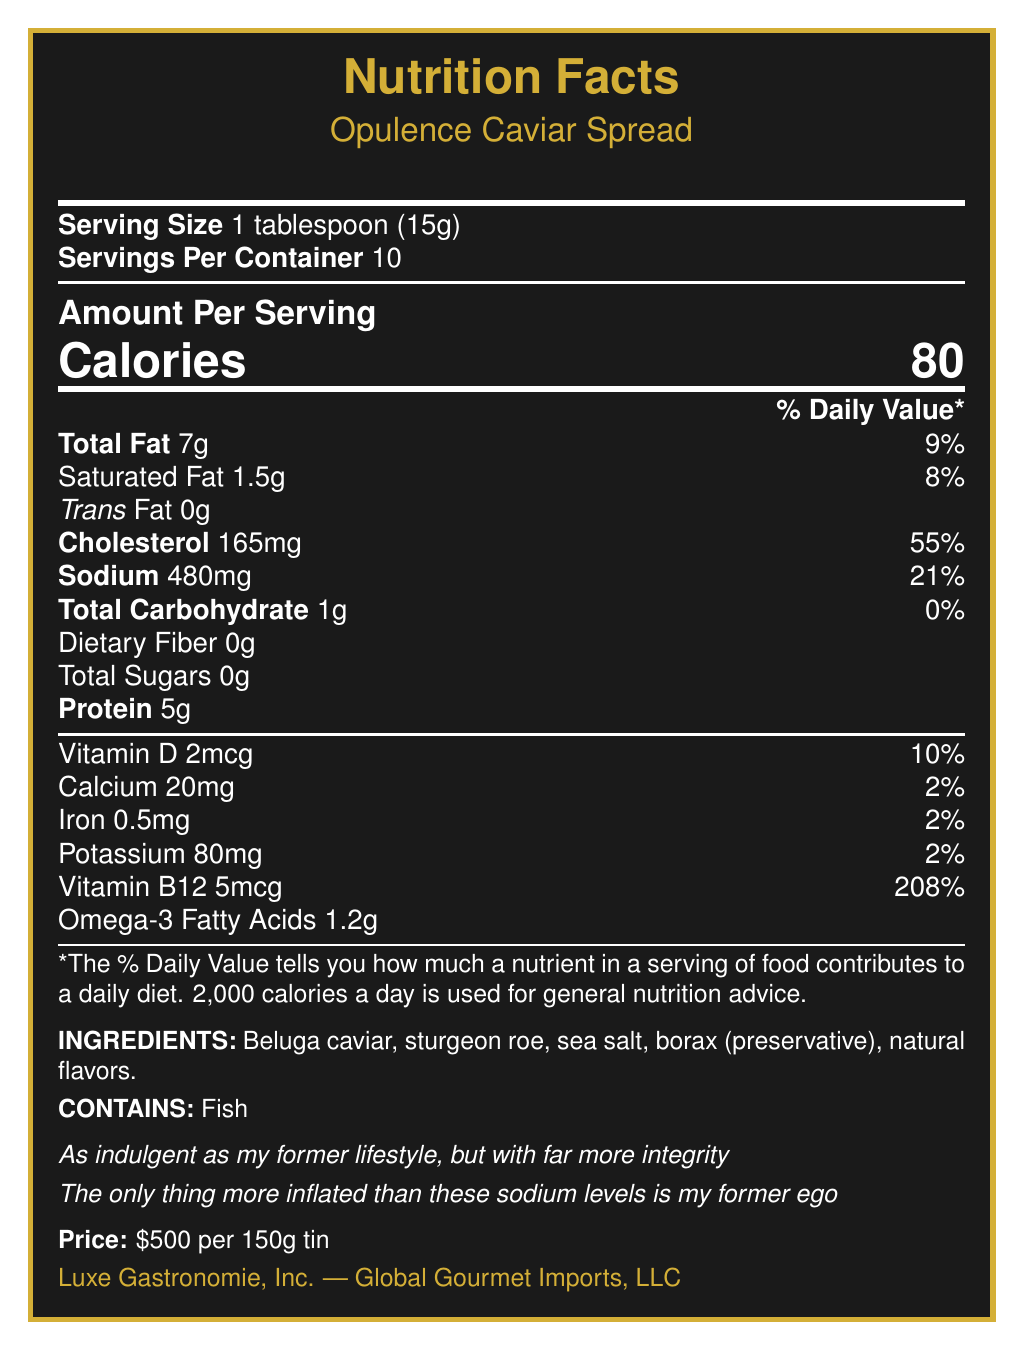what is the serving size for Opulence Caviar Spread? The serving size is clearly indicated as 1 tablespoon (15g) in the document.
Answer: 1 tablespoon (15g) how many calories are there in one serving of Opulence Caviar Spread? The document specifies that each serving contains 80 calories.
Answer: 80 calories how much sodium does one serving of Opulence Caviar Spread contain? The sodium content per serving is given as 480mg.
Answer: 480mg what is the daily value percentage for cholesterol in one serving? The document states that the cholesterol content per serving is 165mg, which is 55% of the daily value.
Answer: 55% list two ingredients in the Opulence Caviar Spread. Among the listed ingredients are Beluga caviar and sturgeon roe, which are the first two items.
Answer: Beluga caviar, sturgeon roe how much Vitamin B12 is in one serving? A. 1mcg B. 2mcg C. 3mcg D. 5mcg The document indicates that each serving contains 5mcg of Vitamin B12.
Answer: D which company distributes the Opulence Caviar Spread? A. Luxe Gastronomie, Inc. B. Caspian Delights Co. C. Global Gourmet Imports, LLC D. Sea Treasures Ltd. The document mentions that Global Gourmet Imports, LLC is the distributor.
Answer: C is this product suitable for someone with a fish allergy? The allergen information clearly states that the product contains fish.
Answer: No describe the main points of the Opulence Caviar Spread nutrition label. The document thoroughly describes the nutritional content and luxurious attributes of the Opulence Caviar Spread, including its ingredient composition, allergen content, and price.
Answer: The Opulence Caviar Spread nutrition label provides details on serving size, calories, macronutrients, and micronutrients per serving. It also lists the ingredients, allergens, and special notes about the product's luxurious nature. The label highlights high sodium and cholesterol content, as well as significant Vitamin B12 levels. The product is packaged in gold-plated tins and priced at $500 per 150g. how much total carbohydrate is there in one serving? The document states that there is 1g of total carbohydrate per serving.
Answer: 1g which vitamin has the highest daily value percentage in the Opulence Caviar Spread? The daily value for Vitamin B12 in one serving is 208%, which is the highest percentage listed.
Answer: Vitamin B12 can you determine the harvesting method of the Opulence Caviar Spread from the document? The special notes specify that it is harvested using traditional methods.
Answer: Yes what acid is present in the Opulence Caviar Spread? A. Omega-3 B. Omega-6 C. Omega-9 D. Linoleic The document lists Omega-3 fatty acids as present in the product.
Answer: A who is the manufacturer of the Opulence Caviar Spread? The manufacturer is Luxe Gastronomie, Inc., as stated in the document.
Answer: Luxe Gastronomie, Inc. does the document indicate any pairing suggestions for the Opulence Caviar Spread? The document provides pairing suggestions such as Dom Pérignon Champagne, mother-of-pearl spoons, and Petrossian blini.
Answer: Yes what is the origin of the Opulence Caviar Spread? The document specifies that the origin of the product is the Caspian Sea, Russia.
Answer: Caspian Sea, Russia how many servings are there per container? The label indicates that there are 10 servings per container.
Answer: 10 can you determine the exact harvesting location from the document? The document states the origin as the Caspian Sea, Russia, but does not provide the exact harvesting location within that region.
Answer: No determine the percentage of daily value for calcium in one serving. The nutrition details specify that one serving contains 20mg of calcium, which is 2% of the daily value.
Answer: 2% 